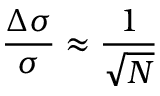<formula> <loc_0><loc_0><loc_500><loc_500>\frac { \Delta \sigma } { \sigma } \approx \frac { 1 } { \sqrt { N } }</formula> 